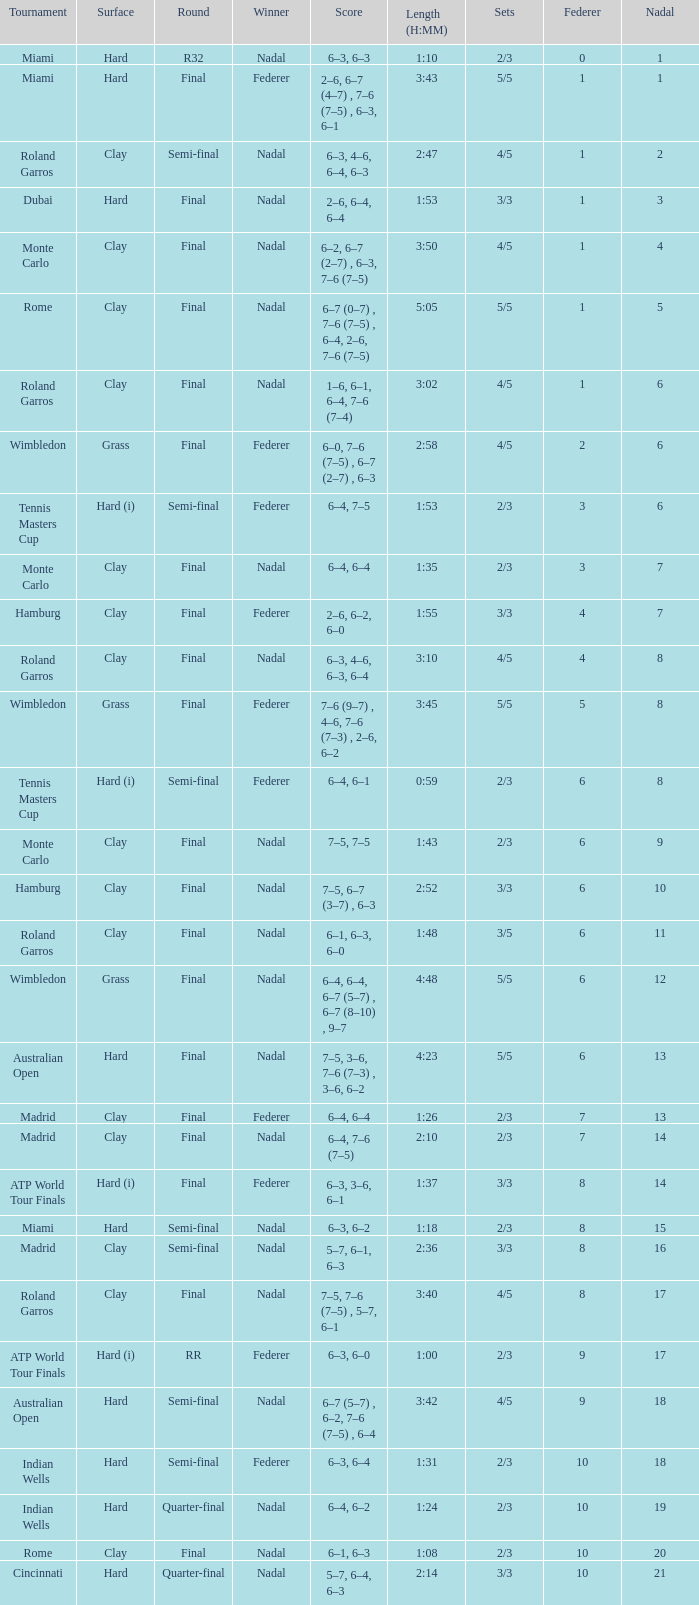What were the sets when federer had 6 and nadal had 13? 5/5. Parse the table in full. {'header': ['Tournament', 'Surface', 'Round', 'Winner', 'Score', 'Length (H:MM)', 'Sets', 'Federer', 'Nadal'], 'rows': [['Miami', 'Hard', 'R32', 'Nadal', '6–3, 6–3', '1:10', '2/3', '0', '1'], ['Miami', 'Hard', 'Final', 'Federer', '2–6, 6–7 (4–7) , 7–6 (7–5) , 6–3, 6–1', '3:43', '5/5', '1', '1'], ['Roland Garros', 'Clay', 'Semi-final', 'Nadal', '6–3, 4–6, 6–4, 6–3', '2:47', '4/5', '1', '2'], ['Dubai', 'Hard', 'Final', 'Nadal', '2–6, 6–4, 6–4', '1:53', '3/3', '1', '3'], ['Monte Carlo', 'Clay', 'Final', 'Nadal', '6–2, 6–7 (2–7) , 6–3, 7–6 (7–5)', '3:50', '4/5', '1', '4'], ['Rome', 'Clay', 'Final', 'Nadal', '6–7 (0–7) , 7–6 (7–5) , 6–4, 2–6, 7–6 (7–5)', '5:05', '5/5', '1', '5'], ['Roland Garros', 'Clay', 'Final', 'Nadal', '1–6, 6–1, 6–4, 7–6 (7–4)', '3:02', '4/5', '1', '6'], ['Wimbledon', 'Grass', 'Final', 'Federer', '6–0, 7–6 (7–5) , 6–7 (2–7) , 6–3', '2:58', '4/5', '2', '6'], ['Tennis Masters Cup', 'Hard (i)', 'Semi-final', 'Federer', '6–4, 7–5', '1:53', '2/3', '3', '6'], ['Monte Carlo', 'Clay', 'Final', 'Nadal', '6–4, 6–4', '1:35', '2/3', '3', '7'], ['Hamburg', 'Clay', 'Final', 'Federer', '2–6, 6–2, 6–0', '1:55', '3/3', '4', '7'], ['Roland Garros', 'Clay', 'Final', 'Nadal', '6–3, 4–6, 6–3, 6–4', '3:10', '4/5', '4', '8'], ['Wimbledon', 'Grass', 'Final', 'Federer', '7–6 (9–7) , 4–6, 7–6 (7–3) , 2–6, 6–2', '3:45', '5/5', '5', '8'], ['Tennis Masters Cup', 'Hard (i)', 'Semi-final', 'Federer', '6–4, 6–1', '0:59', '2/3', '6', '8'], ['Monte Carlo', 'Clay', 'Final', 'Nadal', '7–5, 7–5', '1:43', '2/3', '6', '9'], ['Hamburg', 'Clay', 'Final', 'Nadal', '7–5, 6–7 (3–7) , 6–3', '2:52', '3/3', '6', '10'], ['Roland Garros', 'Clay', 'Final', 'Nadal', '6–1, 6–3, 6–0', '1:48', '3/5', '6', '11'], ['Wimbledon', 'Grass', 'Final', 'Nadal', '6–4, 6–4, 6–7 (5–7) , 6–7 (8–10) , 9–7', '4:48', '5/5', '6', '12'], ['Australian Open', 'Hard', 'Final', 'Nadal', '7–5, 3–6, 7–6 (7–3) , 3–6, 6–2', '4:23', '5/5', '6', '13'], ['Madrid', 'Clay', 'Final', 'Federer', '6–4, 6–4', '1:26', '2/3', '7', '13'], ['Madrid', 'Clay', 'Final', 'Nadal', '6–4, 7–6 (7–5)', '2:10', '2/3', '7', '14'], ['ATP World Tour Finals', 'Hard (i)', 'Final', 'Federer', '6–3, 3–6, 6–1', '1:37', '3/3', '8', '14'], ['Miami', 'Hard', 'Semi-final', 'Nadal', '6–3, 6–2', '1:18', '2/3', '8', '15'], ['Madrid', 'Clay', 'Semi-final', 'Nadal', '5–7, 6–1, 6–3', '2:36', '3/3', '8', '16'], ['Roland Garros', 'Clay', 'Final', 'Nadal', '7–5, 7–6 (7–5) , 5–7, 6–1', '3:40', '4/5', '8', '17'], ['ATP World Tour Finals', 'Hard (i)', 'RR', 'Federer', '6–3, 6–0', '1:00', '2/3', '9', '17'], ['Australian Open', 'Hard', 'Semi-final', 'Nadal', '6–7 (5–7) , 6–2, 7–6 (7–5) , 6–4', '3:42', '4/5', '9', '18'], ['Indian Wells', 'Hard', 'Semi-final', 'Federer', '6–3, 6–4', '1:31', '2/3', '10', '18'], ['Indian Wells', 'Hard', 'Quarter-final', 'Nadal', '6–4, 6–2', '1:24', '2/3', '10', '19'], ['Rome', 'Clay', 'Final', 'Nadal', '6–1, 6–3', '1:08', '2/3', '10', '20'], ['Cincinnati', 'Hard', 'Quarter-final', 'Nadal', '5–7, 6–4, 6–3', '2:14', '3/3', '10', '21']]} 